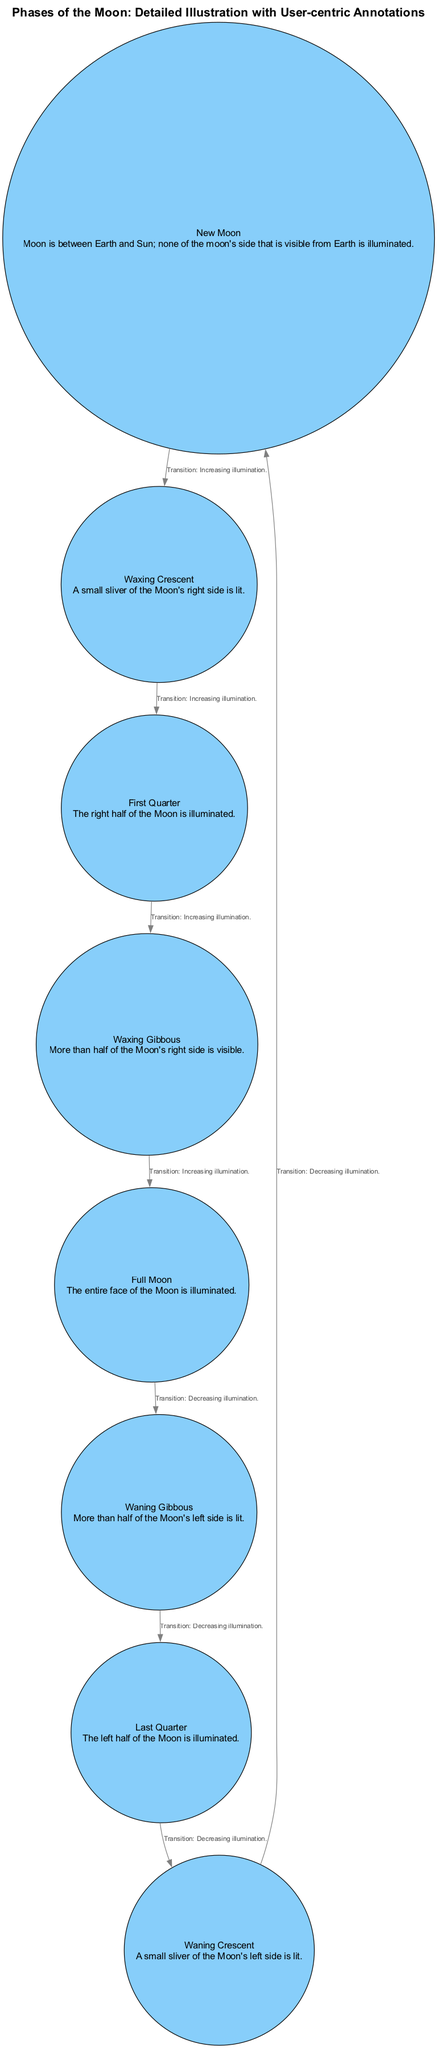What is the description of the Full Moon? The Full Moon node indicates that the entire face of the Moon is illuminated. This is stated directly in the diagram under the label "Full Moon".
Answer: The entire face of the Moon is illuminated How many different phases of the Moon are illustrated in the diagram? By counting the nodes listed, there are eight phases of the Moon labeled in the diagram. Each phase corresponds to a node, indicating their count.
Answer: Eight phases What transition occurs from Waxing Gibbous to Full Moon? The diagram indicates that the transition from Waxing Gibbous to Full Moon is categorized as "Increasing illumination," which is noted along the connecting edge.
Answer: Increasing illumination What side of the Moon is illuminated during the Last Quarter? Referring to the Last Quarter node, the description states that the left half of the Moon is illuminated when in this phase.
Answer: The left half What are the two phases with "Crescent" in their names? The diagram includes two phases labeled with "Crescent": Waxing Crescent and Waning Crescent, as noted in the respective nodes.
Answer: Waxing Crescent and Waning Crescent Which phase follows the First Quarter phase in the sequence? Following the First Quarter phase is the Waxing Gibbous phase, as indicated by the directed edge showing the correct sequence.
Answer: Waxing Gibbous How many transitions involve decreasing illumination? By examining the edges, there are three transitions that involve decreasing illumination: from Full Moon to Waning Gibbous, Waning Gibbous to Last Quarter, and Last Quarter to Waning Crescent. Counting these confirms the number of transitions.
Answer: Three transitions What is the relationship between Waxing Crescent and New Moon? The edge connecting Waxing Crescent and New Moon describes the transition as "Increasing illumination," thereby indicating the relationship between these two phases.
Answer: Increasing illumination 